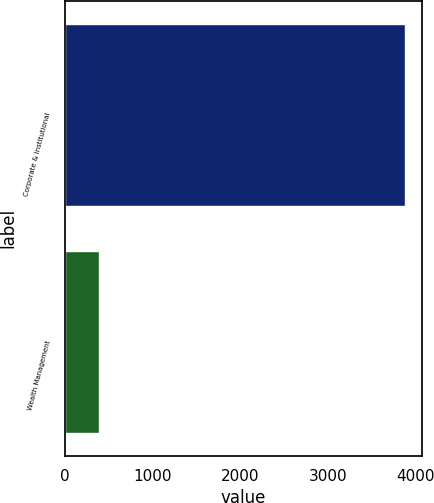Convert chart to OTSL. <chart><loc_0><loc_0><loc_500><loc_500><bar_chart><fcel>Corporate & Institutional<fcel>Wealth Management<nl><fcel>3877.6<fcel>385.2<nl></chart> 